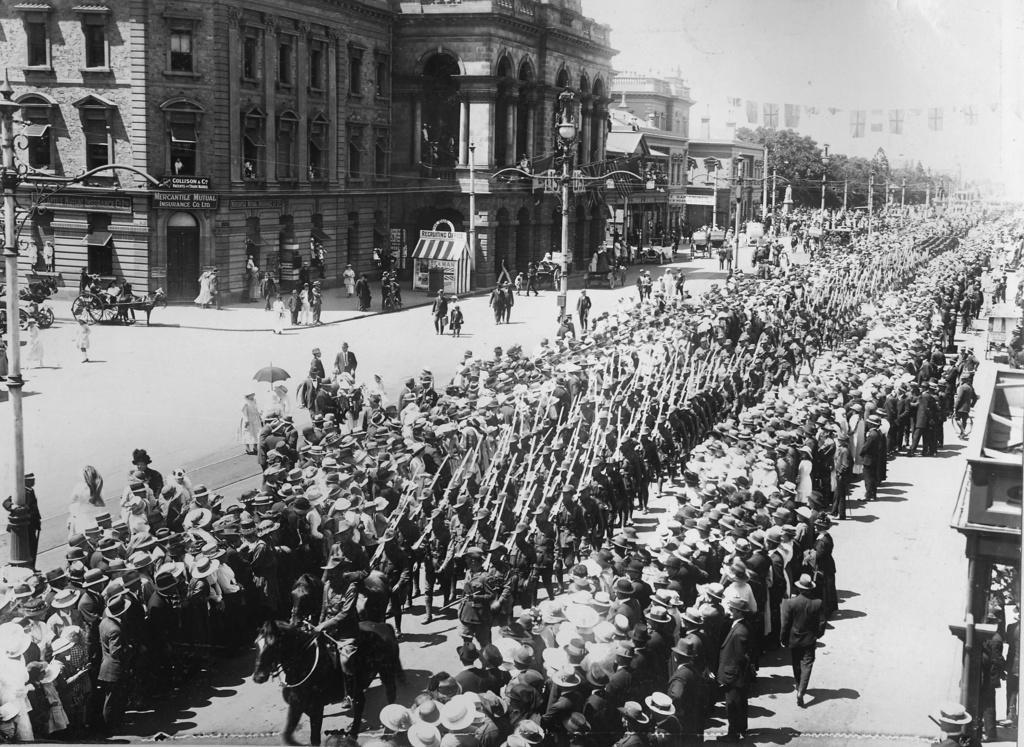What is the color scheme of the image? The image is black and white. What type of structures can be seen in the image? There are buildings in the image. What are the vertical structures on the sides of the road? Street poles are present in the image. What are the tall, illuminated objects on the street poles? Street lights are visible in the image. What mode of transportation is present in the image? Horse carts are in the image. What are the people in the image doing? There are persons walking on the road in the image. What type of fuel is required for the beast to move in the image? There is no beast present in the image, and therefore no fuel is required for it to move. 